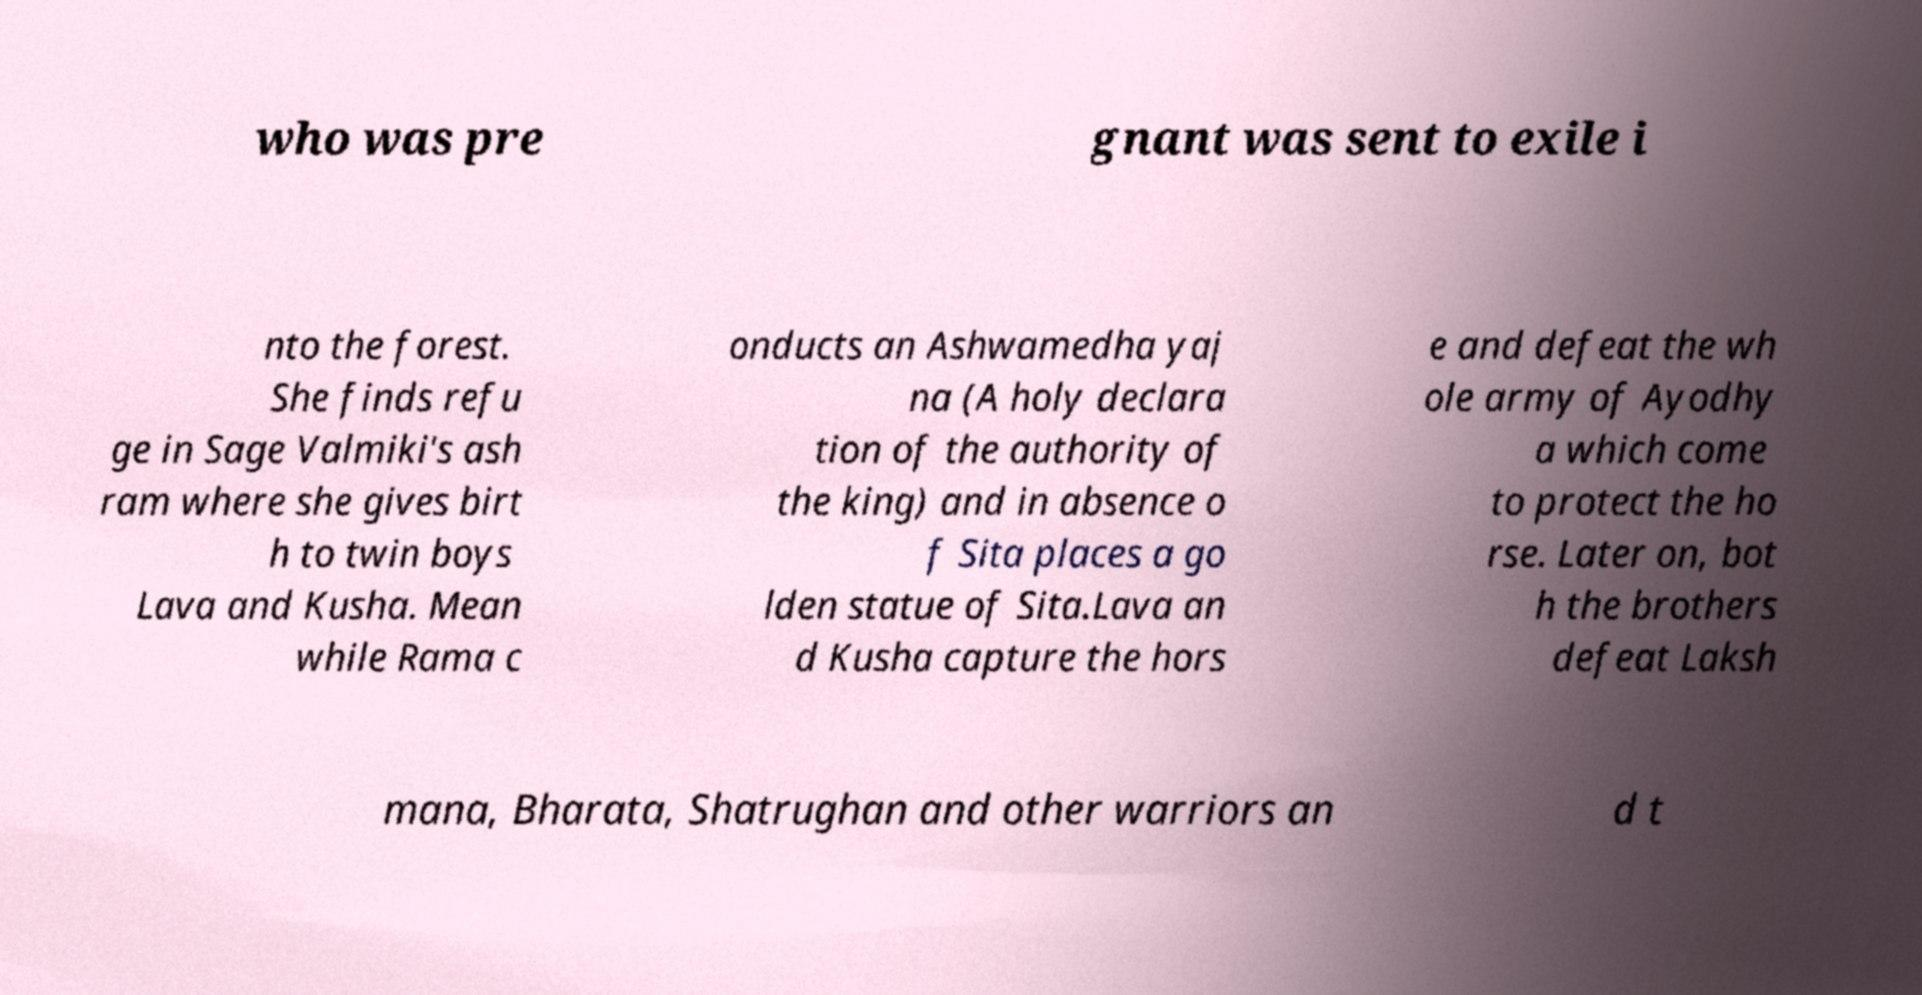Could you assist in decoding the text presented in this image and type it out clearly? who was pre gnant was sent to exile i nto the forest. She finds refu ge in Sage Valmiki's ash ram where she gives birt h to twin boys Lava and Kusha. Mean while Rama c onducts an Ashwamedha yaj na (A holy declara tion of the authority of the king) and in absence o f Sita places a go lden statue of Sita.Lava an d Kusha capture the hors e and defeat the wh ole army of Ayodhy a which come to protect the ho rse. Later on, bot h the brothers defeat Laksh mana, Bharata, Shatrughan and other warriors an d t 